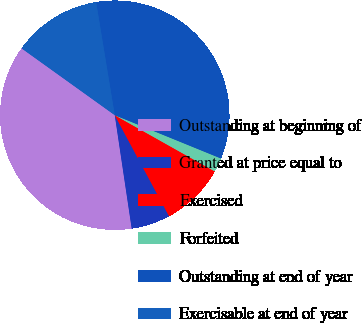Convert chart to OTSL. <chart><loc_0><loc_0><loc_500><loc_500><pie_chart><fcel>Outstanding at beginning of<fcel>Granted at price equal to<fcel>Exercised<fcel>Forfeited<fcel>Outstanding at end of year<fcel>Exercisable at end of year<nl><fcel>37.26%<fcel>5.49%<fcel>9.0%<fcel>1.99%<fcel>33.76%<fcel>12.5%<nl></chart> 